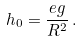Convert formula to latex. <formula><loc_0><loc_0><loc_500><loc_500>h _ { 0 } = \frac { e g } { R ^ { 2 } } \, .</formula> 